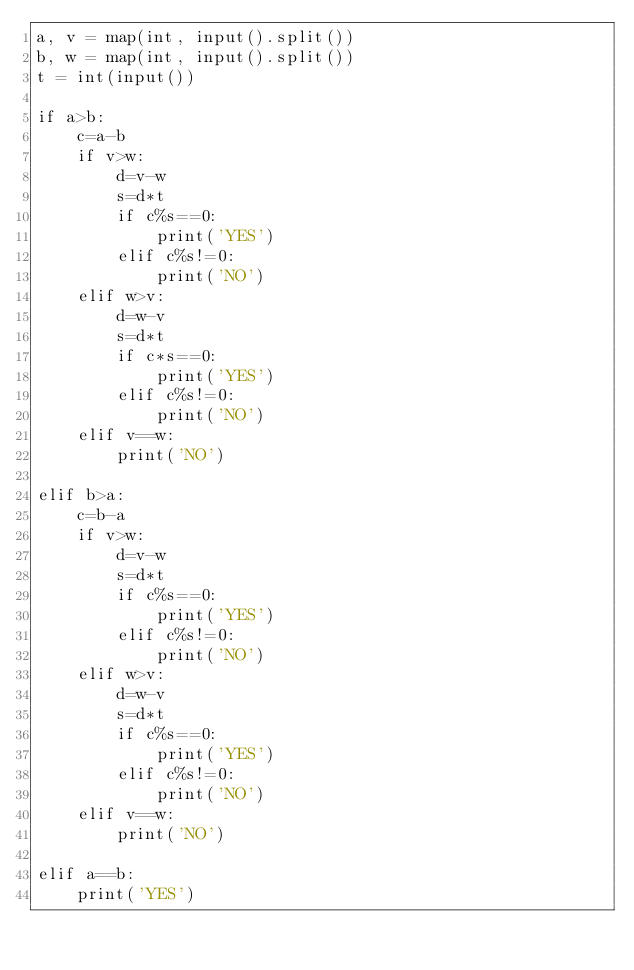Convert code to text. <code><loc_0><loc_0><loc_500><loc_500><_Python_>a, v = map(int, input().split())
b, w = map(int, input().split())
t = int(input())

if a>b:
	c=a-b
	if v>w:
		d=v-w
		s=d*t
		if c%s==0:
			print('YES')
		elif c%s!=0:
			print('NO')
	elif w>v:
		d=w-v
		s=d*t
		if c*s==0:
			print('YES')
		elif c%s!=0:
			print('NO')
	elif v==w:
		print('NO')

elif b>a:
	c=b-a
	if v>w:
		d=v-w
		s=d*t
		if c%s==0:
			print('YES')
		elif c%s!=0:
			print('NO')
	elif w>v:
		d=w-v
		s=d*t
		if c%s==0:
			print('YES')
		elif c%s!=0:
			print('NO')
	elif v==w:
		print('NO')

elif a==b:
	print('YES')</code> 